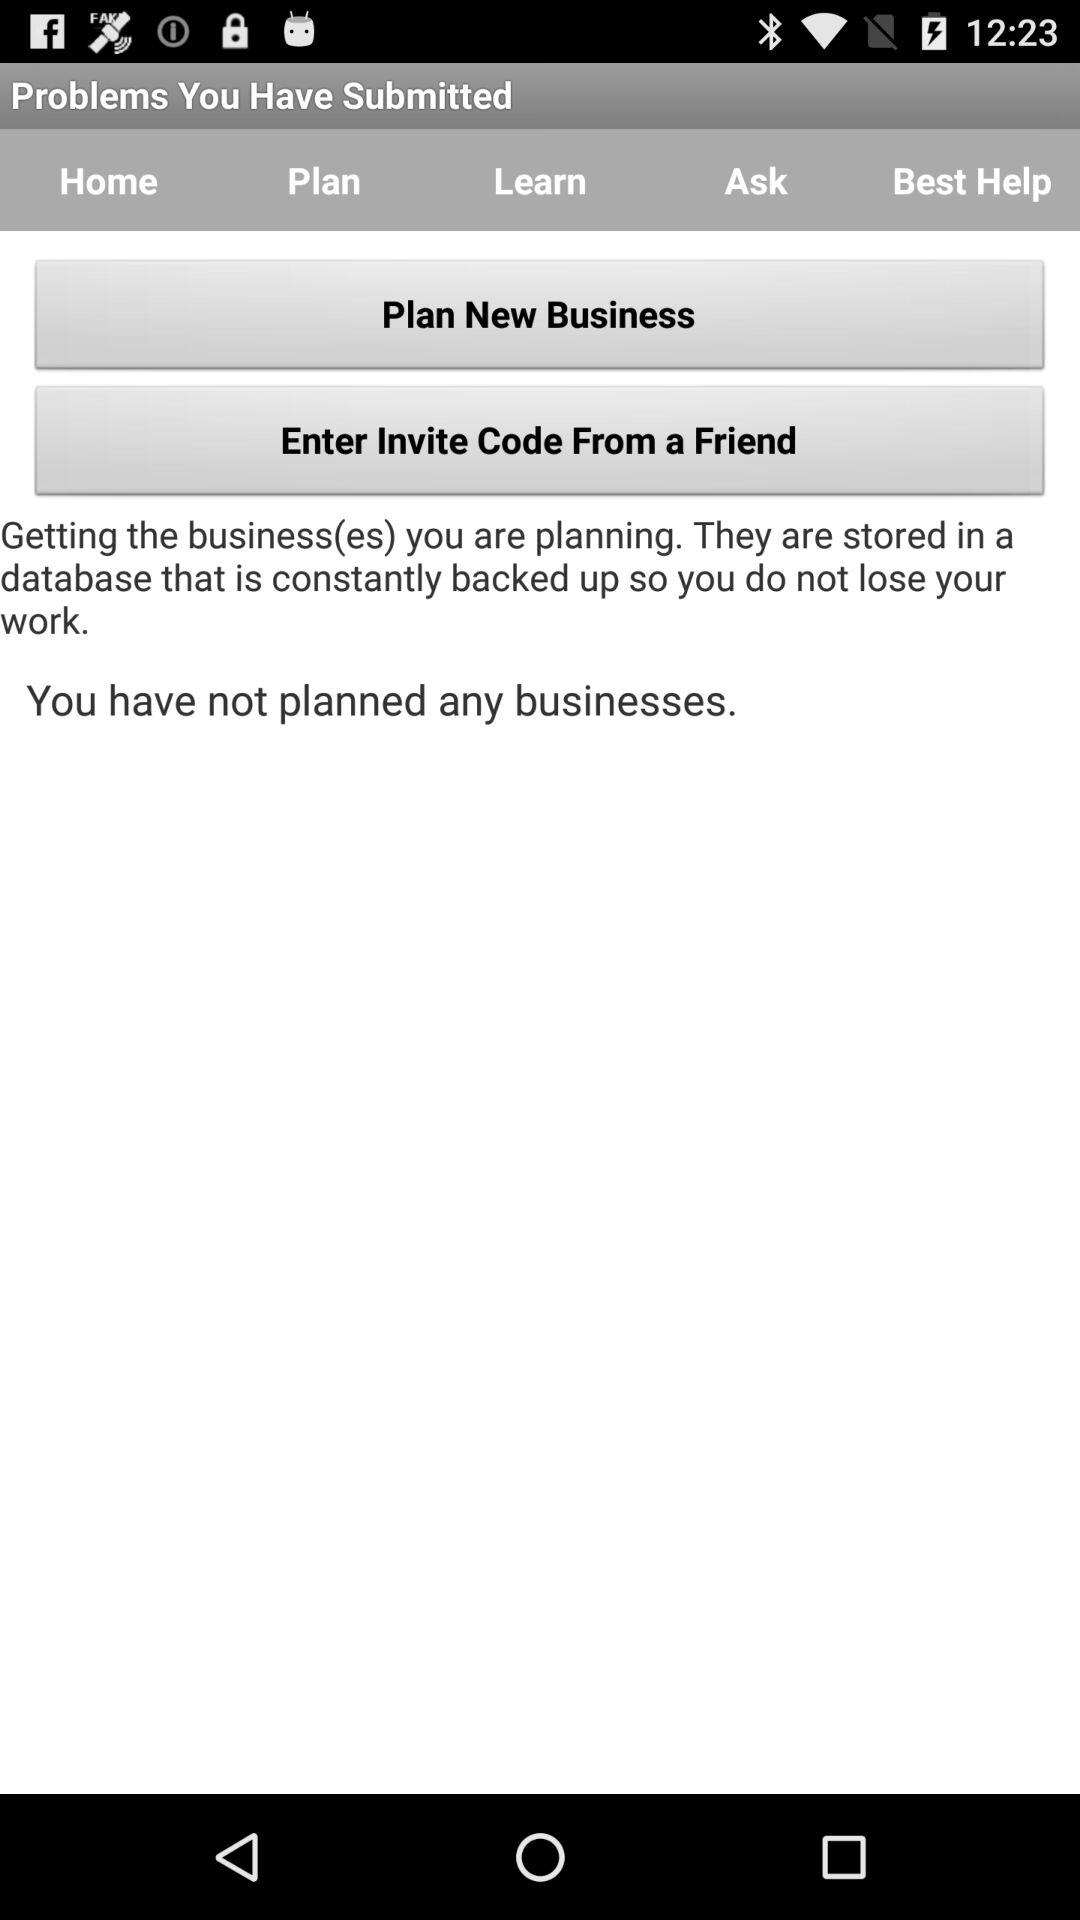Have you planned business? You have not planned any business. 